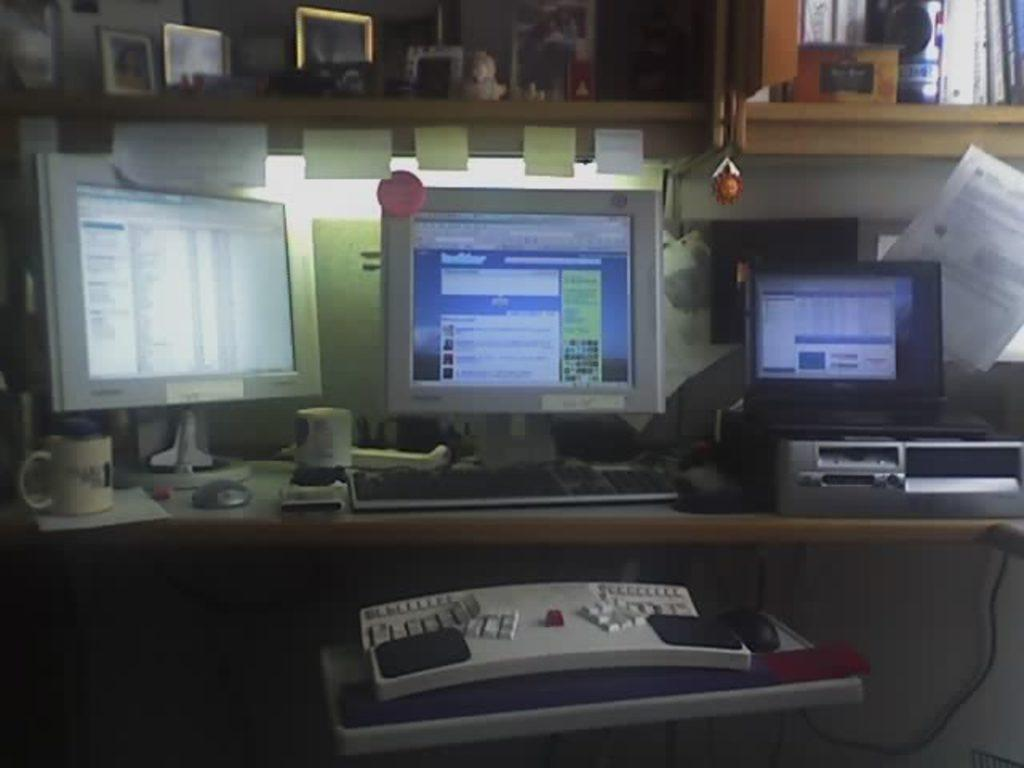What type of furniture is present in the image? There is a table in the image. What other objects can be seen in the image? There are shelves, a keyboard, screens, and books in the image. What type of winter clothing is the self wearing in the image? There is no self or winter clothing present in the image. How does the burn on the keyboard affect its functionality? There is no burn present on the keyboard in the image. 